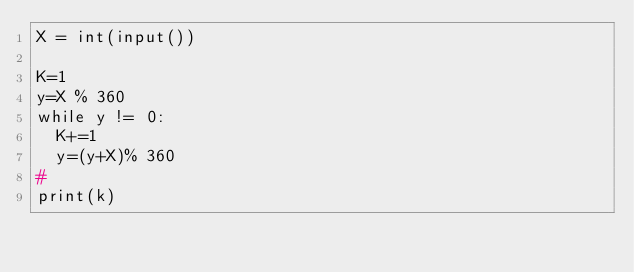Convert code to text. <code><loc_0><loc_0><loc_500><loc_500><_Python_>X = int(input())

K=1
y=X % 360
while y != 0:
  K+=1
  y=(y+X)% 360
#
print(k)

</code> 